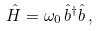<formula> <loc_0><loc_0><loc_500><loc_500>\hat { H } = \omega _ { 0 } \, \hat { b } ^ { \dagger } \hat { b } \, ,</formula> 